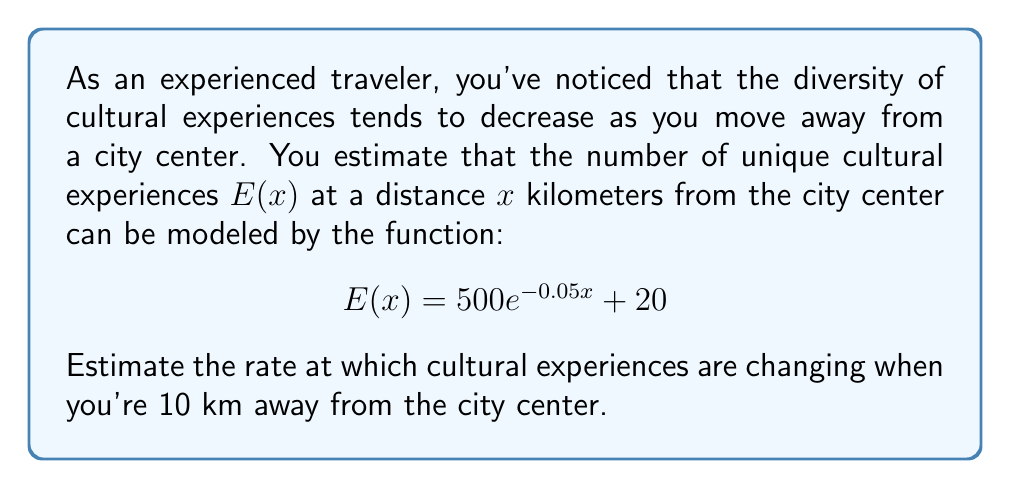What is the answer to this math problem? To solve this problem, we need to find the derivative of $E(x)$ and then evaluate it at $x = 10$. Let's break it down step-by-step:

1) The given function is $E(x) = 500e^{-0.05x} + 20$

2) To find the rate of change, we need to differentiate $E(x)$ with respect to $x$:

   $$\frac{d}{dx}E(x) = \frac{d}{dx}(500e^{-0.05x} + 20)$$

3) Using the chain rule and the fact that the derivative of a constant is 0:

   $$\frac{d}{dx}E(x) = 500 \cdot \frac{d}{dx}(e^{-0.05x}) + 0$$

4) The derivative of $e^x$ is $e^x$, so:

   $$\frac{d}{dx}E(x) = 500 \cdot (-0.05)e^{-0.05x}$$

5) Simplifying:

   $$\frac{d}{dx}E(x) = -25e^{-0.05x}$$

6) Now, we need to evaluate this at $x = 10$:

   $$\frac{d}{dx}E(10) = -25e^{-0.05(10)} = -25e^{-0.5}$$

7) Using a calculator or approximating:

   $$\frac{d}{dx}E(10) \approx -15.18$$

This means that at 10 km from the city center, the rate of change of cultural experiences is approximately -15.18 experiences per kilometer.
Answer: $-15.18$ experiences/km 